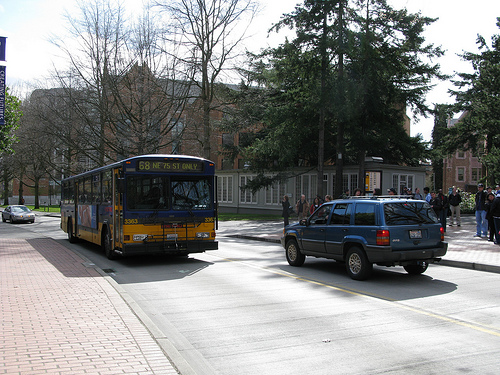How many buses? In the image, there is 1 bus visible, which is a public transit bus identifiable by its size and the route number displayed at the top-front. 